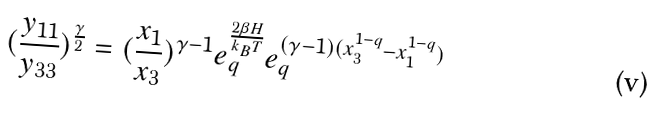<formula> <loc_0><loc_0><loc_500><loc_500>( \frac { y _ { 1 1 } } { y _ { 3 3 } } ) ^ { \frac { \gamma } { 2 } } = ( \frac { x _ { 1 } } { x _ { 3 } } ) ^ { \gamma - 1 } e _ { q } ^ { \frac { 2 \beta H } { k _ { B } T } } e _ { q } ^ { ( \gamma - 1 ) ( x _ { 3 } ^ { 1 - q } - x _ { 1 } ^ { 1 - q } ) }</formula> 